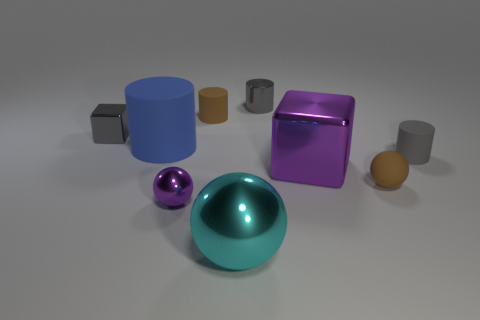Looking at the arrangement of the objects, what can you infer about their placement? The objects are deliberately arranged in a manner that suggests an intentional composition, likely for a display or a render illustrating various geometric forms. Their placement seems carefully spaced, neither too clustered nor too spread out, possibly indicating a design to showcase the unique characteristics of each item, such as color, size, and reflectivity. 